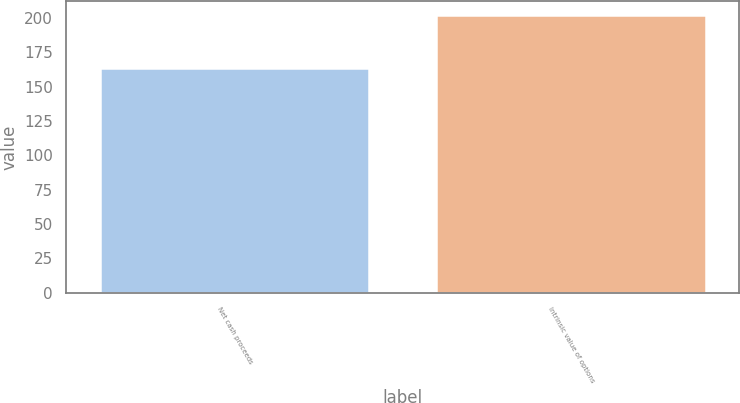Convert chart. <chart><loc_0><loc_0><loc_500><loc_500><bar_chart><fcel>Net cash proceeds<fcel>Intrinsic value of options<nl><fcel>163.7<fcel>201.9<nl></chart> 